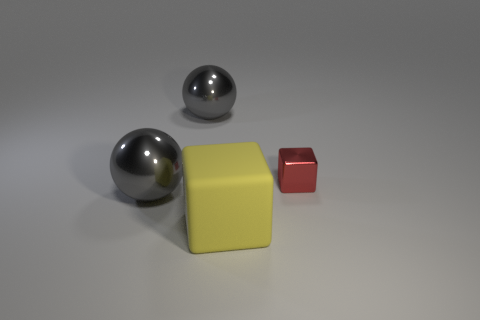The large thing that is behind the yellow cube and in front of the red thing is made of what material?
Provide a short and direct response. Metal. What is the size of the gray metal sphere in front of the large gray object that is behind the large sphere that is in front of the tiny block?
Your answer should be compact. Large. There is a red object; is its size the same as the yellow rubber block that is in front of the red cube?
Offer a very short reply. No. The large yellow thing that is on the left side of the red object has what shape?
Ensure brevity in your answer.  Cube. Are there any balls in front of the large gray ball on the right side of the gray shiny thing that is in front of the red metallic cube?
Offer a very short reply. Yes. There is a tiny object that is the same shape as the big yellow rubber object; what is it made of?
Give a very brief answer. Metal. Is there anything else that has the same material as the red object?
Provide a succinct answer. Yes. What number of spheres are blue metallic things or large yellow things?
Your answer should be compact. 0. Do the yellow block that is on the left side of the shiny block and the cube that is on the right side of the large yellow object have the same size?
Provide a short and direct response. No. There is a cube behind the yellow matte cube to the left of the metallic cube; what is its material?
Ensure brevity in your answer.  Metal. 